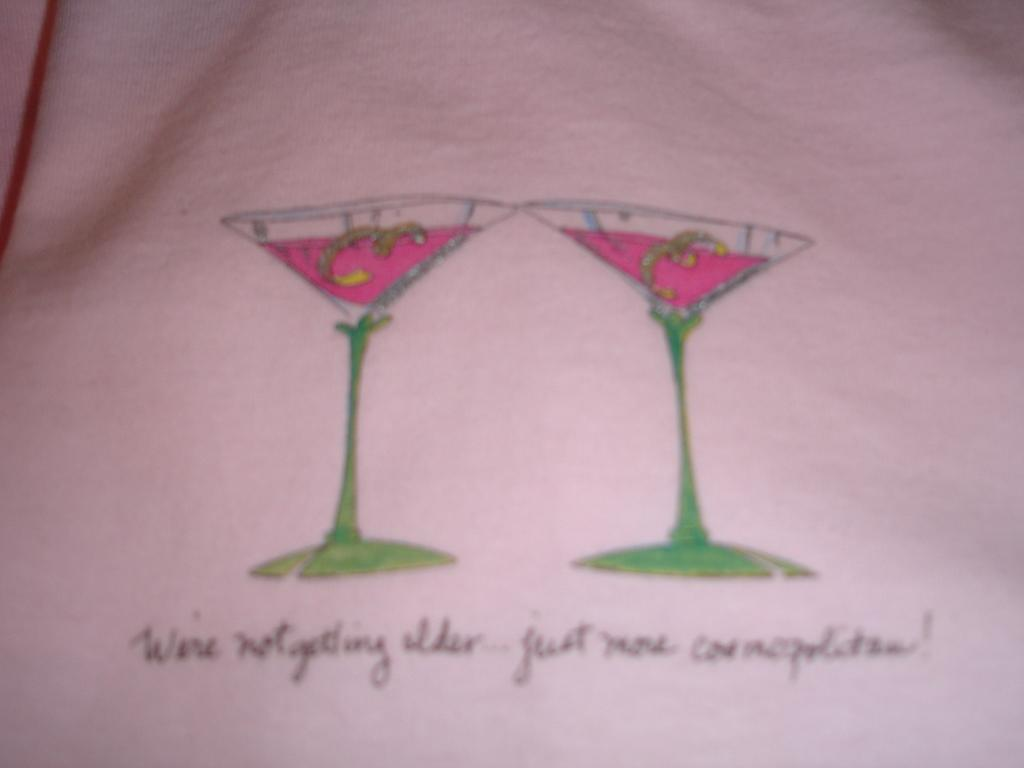What is the main object in the image? There is a paper in the image. What is depicted on the paper? There is a drawing of two glasses of drinks on the paper. Is there any text on the paper? Yes, there is handwritten text at the bottom of the paper. What type of jail is depicted in the drawing on the paper? There is no jail depicted in the drawing on the paper; it features two glasses of drinks. 